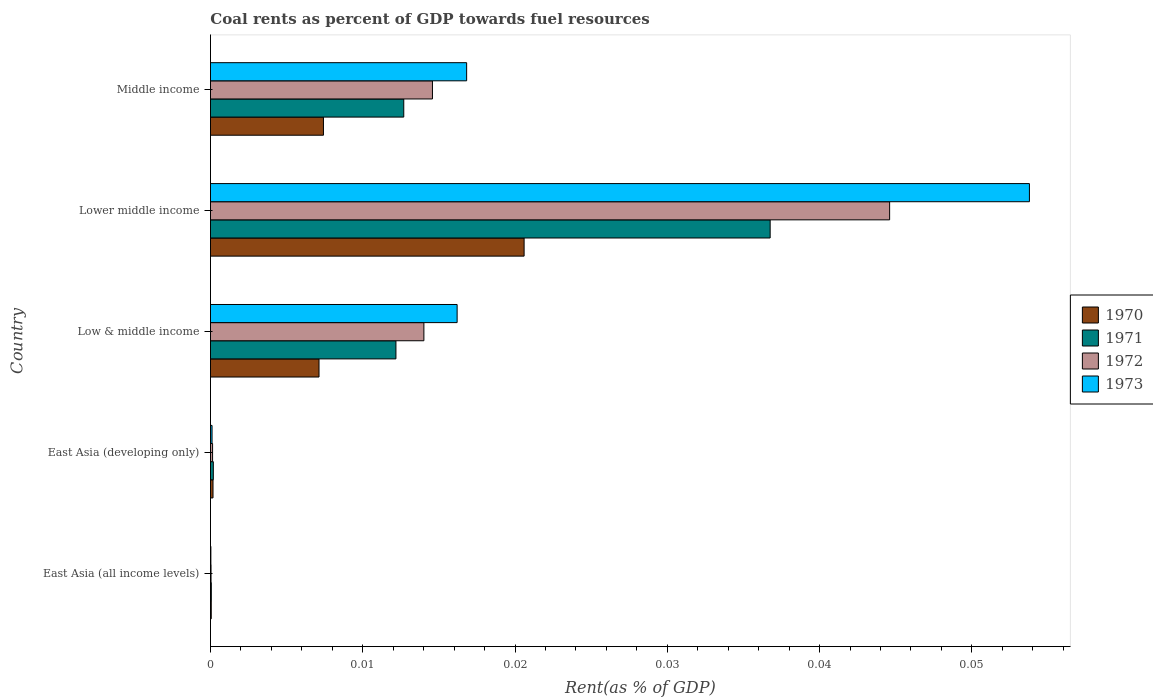How many groups of bars are there?
Provide a short and direct response. 5. Are the number of bars per tick equal to the number of legend labels?
Ensure brevity in your answer.  Yes. Are the number of bars on each tick of the Y-axis equal?
Your answer should be very brief. Yes. What is the label of the 2nd group of bars from the top?
Your response must be concise. Lower middle income. In how many cases, is the number of bars for a given country not equal to the number of legend labels?
Make the answer very short. 0. What is the coal rent in 1972 in Low & middle income?
Offer a very short reply. 0.01. Across all countries, what is the maximum coal rent in 1973?
Provide a succinct answer. 0.05. Across all countries, what is the minimum coal rent in 1973?
Your answer should be compact. 2.64171247686014e-5. In which country was the coal rent in 1971 maximum?
Your answer should be very brief. Lower middle income. In which country was the coal rent in 1972 minimum?
Your answer should be compact. East Asia (all income levels). What is the total coal rent in 1970 in the graph?
Your answer should be compact. 0.04. What is the difference between the coal rent in 1971 in Low & middle income and that in Middle income?
Your answer should be compact. -0. What is the difference between the coal rent in 1973 in Lower middle income and the coal rent in 1971 in East Asia (developing only)?
Give a very brief answer. 0.05. What is the average coal rent in 1970 per country?
Ensure brevity in your answer.  0.01. What is the difference between the coal rent in 1973 and coal rent in 1970 in Middle income?
Your answer should be very brief. 0.01. What is the ratio of the coal rent in 1971 in Low & middle income to that in Lower middle income?
Your answer should be compact. 0.33. Is the difference between the coal rent in 1973 in East Asia (all income levels) and Low & middle income greater than the difference between the coal rent in 1970 in East Asia (all income levels) and Low & middle income?
Make the answer very short. No. What is the difference between the highest and the second highest coal rent in 1970?
Offer a terse response. 0.01. What is the difference between the highest and the lowest coal rent in 1973?
Offer a very short reply. 0.05. Is the sum of the coal rent in 1971 in Lower middle income and Middle income greater than the maximum coal rent in 1973 across all countries?
Keep it short and to the point. No. What does the 1st bar from the top in Low & middle income represents?
Your response must be concise. 1973. How many bars are there?
Make the answer very short. 20. Does the graph contain any zero values?
Give a very brief answer. No. How many legend labels are there?
Give a very brief answer. 4. What is the title of the graph?
Ensure brevity in your answer.  Coal rents as percent of GDP towards fuel resources. What is the label or title of the X-axis?
Offer a terse response. Rent(as % of GDP). What is the label or title of the Y-axis?
Provide a succinct answer. Country. What is the Rent(as % of GDP) of 1970 in East Asia (all income levels)?
Offer a very short reply. 5.1314079013758e-5. What is the Rent(as % of GDP) in 1971 in East Asia (all income levels)?
Make the answer very short. 5.470114168356261e-5. What is the Rent(as % of GDP) in 1972 in East Asia (all income levels)?
Ensure brevity in your answer.  3.67730514806032e-5. What is the Rent(as % of GDP) of 1973 in East Asia (all income levels)?
Your answer should be compact. 2.64171247686014e-5. What is the Rent(as % of GDP) in 1970 in East Asia (developing only)?
Keep it short and to the point. 0. What is the Rent(as % of GDP) in 1971 in East Asia (developing only)?
Your response must be concise. 0. What is the Rent(as % of GDP) of 1972 in East Asia (developing only)?
Provide a succinct answer. 0. What is the Rent(as % of GDP) of 1973 in East Asia (developing only)?
Keep it short and to the point. 0. What is the Rent(as % of GDP) in 1970 in Low & middle income?
Your response must be concise. 0.01. What is the Rent(as % of GDP) in 1971 in Low & middle income?
Provide a succinct answer. 0.01. What is the Rent(as % of GDP) in 1972 in Low & middle income?
Your answer should be very brief. 0.01. What is the Rent(as % of GDP) in 1973 in Low & middle income?
Offer a terse response. 0.02. What is the Rent(as % of GDP) in 1970 in Lower middle income?
Your answer should be very brief. 0.02. What is the Rent(as % of GDP) of 1971 in Lower middle income?
Keep it short and to the point. 0.04. What is the Rent(as % of GDP) of 1972 in Lower middle income?
Your answer should be compact. 0.04. What is the Rent(as % of GDP) of 1973 in Lower middle income?
Make the answer very short. 0.05. What is the Rent(as % of GDP) of 1970 in Middle income?
Provide a short and direct response. 0.01. What is the Rent(as % of GDP) in 1971 in Middle income?
Give a very brief answer. 0.01. What is the Rent(as % of GDP) of 1972 in Middle income?
Provide a short and direct response. 0.01. What is the Rent(as % of GDP) of 1973 in Middle income?
Keep it short and to the point. 0.02. Across all countries, what is the maximum Rent(as % of GDP) of 1970?
Offer a terse response. 0.02. Across all countries, what is the maximum Rent(as % of GDP) in 1971?
Make the answer very short. 0.04. Across all countries, what is the maximum Rent(as % of GDP) in 1972?
Ensure brevity in your answer.  0.04. Across all countries, what is the maximum Rent(as % of GDP) of 1973?
Keep it short and to the point. 0.05. Across all countries, what is the minimum Rent(as % of GDP) in 1970?
Make the answer very short. 5.1314079013758e-5. Across all countries, what is the minimum Rent(as % of GDP) in 1971?
Ensure brevity in your answer.  5.470114168356261e-5. Across all countries, what is the minimum Rent(as % of GDP) in 1972?
Your answer should be very brief. 3.67730514806032e-5. Across all countries, what is the minimum Rent(as % of GDP) in 1973?
Your response must be concise. 2.64171247686014e-5. What is the total Rent(as % of GDP) in 1970 in the graph?
Give a very brief answer. 0.04. What is the total Rent(as % of GDP) in 1971 in the graph?
Offer a very short reply. 0.06. What is the total Rent(as % of GDP) in 1972 in the graph?
Offer a very short reply. 0.07. What is the total Rent(as % of GDP) in 1973 in the graph?
Your answer should be very brief. 0.09. What is the difference between the Rent(as % of GDP) of 1970 in East Asia (all income levels) and that in East Asia (developing only)?
Make the answer very short. -0. What is the difference between the Rent(as % of GDP) in 1971 in East Asia (all income levels) and that in East Asia (developing only)?
Make the answer very short. -0. What is the difference between the Rent(as % of GDP) in 1972 in East Asia (all income levels) and that in East Asia (developing only)?
Give a very brief answer. -0. What is the difference between the Rent(as % of GDP) in 1973 in East Asia (all income levels) and that in East Asia (developing only)?
Your response must be concise. -0. What is the difference between the Rent(as % of GDP) in 1970 in East Asia (all income levels) and that in Low & middle income?
Your answer should be compact. -0.01. What is the difference between the Rent(as % of GDP) in 1971 in East Asia (all income levels) and that in Low & middle income?
Your response must be concise. -0.01. What is the difference between the Rent(as % of GDP) of 1972 in East Asia (all income levels) and that in Low & middle income?
Keep it short and to the point. -0.01. What is the difference between the Rent(as % of GDP) in 1973 in East Asia (all income levels) and that in Low & middle income?
Provide a succinct answer. -0.02. What is the difference between the Rent(as % of GDP) of 1970 in East Asia (all income levels) and that in Lower middle income?
Offer a terse response. -0.02. What is the difference between the Rent(as % of GDP) of 1971 in East Asia (all income levels) and that in Lower middle income?
Keep it short and to the point. -0.04. What is the difference between the Rent(as % of GDP) in 1972 in East Asia (all income levels) and that in Lower middle income?
Your response must be concise. -0.04. What is the difference between the Rent(as % of GDP) of 1973 in East Asia (all income levels) and that in Lower middle income?
Your response must be concise. -0.05. What is the difference between the Rent(as % of GDP) of 1970 in East Asia (all income levels) and that in Middle income?
Offer a very short reply. -0.01. What is the difference between the Rent(as % of GDP) in 1971 in East Asia (all income levels) and that in Middle income?
Offer a terse response. -0.01. What is the difference between the Rent(as % of GDP) of 1972 in East Asia (all income levels) and that in Middle income?
Your response must be concise. -0.01. What is the difference between the Rent(as % of GDP) in 1973 in East Asia (all income levels) and that in Middle income?
Your response must be concise. -0.02. What is the difference between the Rent(as % of GDP) in 1970 in East Asia (developing only) and that in Low & middle income?
Make the answer very short. -0.01. What is the difference between the Rent(as % of GDP) of 1971 in East Asia (developing only) and that in Low & middle income?
Keep it short and to the point. -0.01. What is the difference between the Rent(as % of GDP) of 1972 in East Asia (developing only) and that in Low & middle income?
Your answer should be very brief. -0.01. What is the difference between the Rent(as % of GDP) in 1973 in East Asia (developing only) and that in Low & middle income?
Provide a short and direct response. -0.02. What is the difference between the Rent(as % of GDP) of 1970 in East Asia (developing only) and that in Lower middle income?
Provide a short and direct response. -0.02. What is the difference between the Rent(as % of GDP) of 1971 in East Asia (developing only) and that in Lower middle income?
Provide a short and direct response. -0.04. What is the difference between the Rent(as % of GDP) of 1972 in East Asia (developing only) and that in Lower middle income?
Offer a very short reply. -0.04. What is the difference between the Rent(as % of GDP) of 1973 in East Asia (developing only) and that in Lower middle income?
Offer a very short reply. -0.05. What is the difference between the Rent(as % of GDP) in 1970 in East Asia (developing only) and that in Middle income?
Ensure brevity in your answer.  -0.01. What is the difference between the Rent(as % of GDP) in 1971 in East Asia (developing only) and that in Middle income?
Give a very brief answer. -0.01. What is the difference between the Rent(as % of GDP) of 1972 in East Asia (developing only) and that in Middle income?
Provide a succinct answer. -0.01. What is the difference between the Rent(as % of GDP) in 1973 in East Asia (developing only) and that in Middle income?
Your response must be concise. -0.02. What is the difference between the Rent(as % of GDP) of 1970 in Low & middle income and that in Lower middle income?
Provide a succinct answer. -0.01. What is the difference between the Rent(as % of GDP) in 1971 in Low & middle income and that in Lower middle income?
Your answer should be very brief. -0.02. What is the difference between the Rent(as % of GDP) of 1972 in Low & middle income and that in Lower middle income?
Give a very brief answer. -0.03. What is the difference between the Rent(as % of GDP) of 1973 in Low & middle income and that in Lower middle income?
Offer a very short reply. -0.04. What is the difference between the Rent(as % of GDP) in 1970 in Low & middle income and that in Middle income?
Offer a very short reply. -0. What is the difference between the Rent(as % of GDP) in 1971 in Low & middle income and that in Middle income?
Offer a terse response. -0. What is the difference between the Rent(as % of GDP) in 1972 in Low & middle income and that in Middle income?
Provide a succinct answer. -0. What is the difference between the Rent(as % of GDP) of 1973 in Low & middle income and that in Middle income?
Provide a short and direct response. -0. What is the difference between the Rent(as % of GDP) in 1970 in Lower middle income and that in Middle income?
Your response must be concise. 0.01. What is the difference between the Rent(as % of GDP) in 1971 in Lower middle income and that in Middle income?
Provide a short and direct response. 0.02. What is the difference between the Rent(as % of GDP) in 1973 in Lower middle income and that in Middle income?
Your answer should be compact. 0.04. What is the difference between the Rent(as % of GDP) in 1970 in East Asia (all income levels) and the Rent(as % of GDP) in 1971 in East Asia (developing only)?
Your response must be concise. -0. What is the difference between the Rent(as % of GDP) in 1970 in East Asia (all income levels) and the Rent(as % of GDP) in 1972 in East Asia (developing only)?
Keep it short and to the point. -0. What is the difference between the Rent(as % of GDP) in 1970 in East Asia (all income levels) and the Rent(as % of GDP) in 1973 in East Asia (developing only)?
Your answer should be compact. -0. What is the difference between the Rent(as % of GDP) of 1971 in East Asia (all income levels) and the Rent(as % of GDP) of 1972 in East Asia (developing only)?
Ensure brevity in your answer.  -0. What is the difference between the Rent(as % of GDP) of 1972 in East Asia (all income levels) and the Rent(as % of GDP) of 1973 in East Asia (developing only)?
Ensure brevity in your answer.  -0. What is the difference between the Rent(as % of GDP) in 1970 in East Asia (all income levels) and the Rent(as % of GDP) in 1971 in Low & middle income?
Your response must be concise. -0.01. What is the difference between the Rent(as % of GDP) of 1970 in East Asia (all income levels) and the Rent(as % of GDP) of 1972 in Low & middle income?
Provide a short and direct response. -0.01. What is the difference between the Rent(as % of GDP) in 1970 in East Asia (all income levels) and the Rent(as % of GDP) in 1973 in Low & middle income?
Your answer should be compact. -0.02. What is the difference between the Rent(as % of GDP) of 1971 in East Asia (all income levels) and the Rent(as % of GDP) of 1972 in Low & middle income?
Provide a succinct answer. -0.01. What is the difference between the Rent(as % of GDP) in 1971 in East Asia (all income levels) and the Rent(as % of GDP) in 1973 in Low & middle income?
Give a very brief answer. -0.02. What is the difference between the Rent(as % of GDP) of 1972 in East Asia (all income levels) and the Rent(as % of GDP) of 1973 in Low & middle income?
Keep it short and to the point. -0.02. What is the difference between the Rent(as % of GDP) of 1970 in East Asia (all income levels) and the Rent(as % of GDP) of 1971 in Lower middle income?
Make the answer very short. -0.04. What is the difference between the Rent(as % of GDP) of 1970 in East Asia (all income levels) and the Rent(as % of GDP) of 1972 in Lower middle income?
Provide a succinct answer. -0.04. What is the difference between the Rent(as % of GDP) in 1970 in East Asia (all income levels) and the Rent(as % of GDP) in 1973 in Lower middle income?
Offer a terse response. -0.05. What is the difference between the Rent(as % of GDP) in 1971 in East Asia (all income levels) and the Rent(as % of GDP) in 1972 in Lower middle income?
Provide a succinct answer. -0.04. What is the difference between the Rent(as % of GDP) of 1971 in East Asia (all income levels) and the Rent(as % of GDP) of 1973 in Lower middle income?
Your answer should be compact. -0.05. What is the difference between the Rent(as % of GDP) in 1972 in East Asia (all income levels) and the Rent(as % of GDP) in 1973 in Lower middle income?
Offer a very short reply. -0.05. What is the difference between the Rent(as % of GDP) of 1970 in East Asia (all income levels) and the Rent(as % of GDP) of 1971 in Middle income?
Offer a very short reply. -0.01. What is the difference between the Rent(as % of GDP) of 1970 in East Asia (all income levels) and the Rent(as % of GDP) of 1972 in Middle income?
Keep it short and to the point. -0.01. What is the difference between the Rent(as % of GDP) in 1970 in East Asia (all income levels) and the Rent(as % of GDP) in 1973 in Middle income?
Your response must be concise. -0.02. What is the difference between the Rent(as % of GDP) of 1971 in East Asia (all income levels) and the Rent(as % of GDP) of 1972 in Middle income?
Your answer should be very brief. -0.01. What is the difference between the Rent(as % of GDP) in 1971 in East Asia (all income levels) and the Rent(as % of GDP) in 1973 in Middle income?
Provide a short and direct response. -0.02. What is the difference between the Rent(as % of GDP) in 1972 in East Asia (all income levels) and the Rent(as % of GDP) in 1973 in Middle income?
Ensure brevity in your answer.  -0.02. What is the difference between the Rent(as % of GDP) of 1970 in East Asia (developing only) and the Rent(as % of GDP) of 1971 in Low & middle income?
Give a very brief answer. -0.01. What is the difference between the Rent(as % of GDP) in 1970 in East Asia (developing only) and the Rent(as % of GDP) in 1972 in Low & middle income?
Your answer should be very brief. -0.01. What is the difference between the Rent(as % of GDP) of 1970 in East Asia (developing only) and the Rent(as % of GDP) of 1973 in Low & middle income?
Give a very brief answer. -0.02. What is the difference between the Rent(as % of GDP) of 1971 in East Asia (developing only) and the Rent(as % of GDP) of 1972 in Low & middle income?
Offer a terse response. -0.01. What is the difference between the Rent(as % of GDP) in 1971 in East Asia (developing only) and the Rent(as % of GDP) in 1973 in Low & middle income?
Make the answer very short. -0.02. What is the difference between the Rent(as % of GDP) of 1972 in East Asia (developing only) and the Rent(as % of GDP) of 1973 in Low & middle income?
Give a very brief answer. -0.02. What is the difference between the Rent(as % of GDP) of 1970 in East Asia (developing only) and the Rent(as % of GDP) of 1971 in Lower middle income?
Provide a short and direct response. -0.04. What is the difference between the Rent(as % of GDP) in 1970 in East Asia (developing only) and the Rent(as % of GDP) in 1972 in Lower middle income?
Your answer should be compact. -0.04. What is the difference between the Rent(as % of GDP) of 1970 in East Asia (developing only) and the Rent(as % of GDP) of 1973 in Lower middle income?
Give a very brief answer. -0.05. What is the difference between the Rent(as % of GDP) of 1971 in East Asia (developing only) and the Rent(as % of GDP) of 1972 in Lower middle income?
Your response must be concise. -0.04. What is the difference between the Rent(as % of GDP) in 1971 in East Asia (developing only) and the Rent(as % of GDP) in 1973 in Lower middle income?
Provide a short and direct response. -0.05. What is the difference between the Rent(as % of GDP) in 1972 in East Asia (developing only) and the Rent(as % of GDP) in 1973 in Lower middle income?
Make the answer very short. -0.05. What is the difference between the Rent(as % of GDP) in 1970 in East Asia (developing only) and the Rent(as % of GDP) in 1971 in Middle income?
Provide a succinct answer. -0.01. What is the difference between the Rent(as % of GDP) in 1970 in East Asia (developing only) and the Rent(as % of GDP) in 1972 in Middle income?
Your answer should be very brief. -0.01. What is the difference between the Rent(as % of GDP) of 1970 in East Asia (developing only) and the Rent(as % of GDP) of 1973 in Middle income?
Your answer should be compact. -0.02. What is the difference between the Rent(as % of GDP) of 1971 in East Asia (developing only) and the Rent(as % of GDP) of 1972 in Middle income?
Your answer should be compact. -0.01. What is the difference between the Rent(as % of GDP) in 1971 in East Asia (developing only) and the Rent(as % of GDP) in 1973 in Middle income?
Ensure brevity in your answer.  -0.02. What is the difference between the Rent(as % of GDP) in 1972 in East Asia (developing only) and the Rent(as % of GDP) in 1973 in Middle income?
Give a very brief answer. -0.02. What is the difference between the Rent(as % of GDP) in 1970 in Low & middle income and the Rent(as % of GDP) in 1971 in Lower middle income?
Offer a terse response. -0.03. What is the difference between the Rent(as % of GDP) in 1970 in Low & middle income and the Rent(as % of GDP) in 1972 in Lower middle income?
Make the answer very short. -0.04. What is the difference between the Rent(as % of GDP) of 1970 in Low & middle income and the Rent(as % of GDP) of 1973 in Lower middle income?
Offer a terse response. -0.05. What is the difference between the Rent(as % of GDP) of 1971 in Low & middle income and the Rent(as % of GDP) of 1972 in Lower middle income?
Offer a very short reply. -0.03. What is the difference between the Rent(as % of GDP) in 1971 in Low & middle income and the Rent(as % of GDP) in 1973 in Lower middle income?
Provide a short and direct response. -0.04. What is the difference between the Rent(as % of GDP) in 1972 in Low & middle income and the Rent(as % of GDP) in 1973 in Lower middle income?
Offer a very short reply. -0.04. What is the difference between the Rent(as % of GDP) in 1970 in Low & middle income and the Rent(as % of GDP) in 1971 in Middle income?
Ensure brevity in your answer.  -0.01. What is the difference between the Rent(as % of GDP) of 1970 in Low & middle income and the Rent(as % of GDP) of 1972 in Middle income?
Provide a succinct answer. -0.01. What is the difference between the Rent(as % of GDP) of 1970 in Low & middle income and the Rent(as % of GDP) of 1973 in Middle income?
Give a very brief answer. -0.01. What is the difference between the Rent(as % of GDP) of 1971 in Low & middle income and the Rent(as % of GDP) of 1972 in Middle income?
Ensure brevity in your answer.  -0. What is the difference between the Rent(as % of GDP) of 1971 in Low & middle income and the Rent(as % of GDP) of 1973 in Middle income?
Your answer should be compact. -0. What is the difference between the Rent(as % of GDP) of 1972 in Low & middle income and the Rent(as % of GDP) of 1973 in Middle income?
Give a very brief answer. -0. What is the difference between the Rent(as % of GDP) of 1970 in Lower middle income and the Rent(as % of GDP) of 1971 in Middle income?
Offer a terse response. 0.01. What is the difference between the Rent(as % of GDP) of 1970 in Lower middle income and the Rent(as % of GDP) of 1972 in Middle income?
Offer a terse response. 0.01. What is the difference between the Rent(as % of GDP) in 1970 in Lower middle income and the Rent(as % of GDP) in 1973 in Middle income?
Make the answer very short. 0. What is the difference between the Rent(as % of GDP) of 1971 in Lower middle income and the Rent(as % of GDP) of 1972 in Middle income?
Give a very brief answer. 0.02. What is the difference between the Rent(as % of GDP) of 1971 in Lower middle income and the Rent(as % of GDP) of 1973 in Middle income?
Make the answer very short. 0.02. What is the difference between the Rent(as % of GDP) in 1972 in Lower middle income and the Rent(as % of GDP) in 1973 in Middle income?
Offer a very short reply. 0.03. What is the average Rent(as % of GDP) in 1970 per country?
Give a very brief answer. 0.01. What is the average Rent(as % of GDP) of 1971 per country?
Give a very brief answer. 0.01. What is the average Rent(as % of GDP) in 1972 per country?
Make the answer very short. 0.01. What is the average Rent(as % of GDP) in 1973 per country?
Give a very brief answer. 0.02. What is the difference between the Rent(as % of GDP) in 1970 and Rent(as % of GDP) in 1971 in East Asia (all income levels)?
Provide a succinct answer. -0. What is the difference between the Rent(as % of GDP) in 1970 and Rent(as % of GDP) in 1972 in East Asia (all income levels)?
Give a very brief answer. 0. What is the difference between the Rent(as % of GDP) in 1971 and Rent(as % of GDP) in 1972 in East Asia (all income levels)?
Offer a terse response. 0. What is the difference between the Rent(as % of GDP) in 1970 and Rent(as % of GDP) in 1971 in East Asia (developing only)?
Offer a very short reply. -0. What is the difference between the Rent(as % of GDP) of 1970 and Rent(as % of GDP) of 1972 in East Asia (developing only)?
Make the answer very short. 0. What is the difference between the Rent(as % of GDP) in 1970 and Rent(as % of GDP) in 1971 in Low & middle income?
Keep it short and to the point. -0.01. What is the difference between the Rent(as % of GDP) of 1970 and Rent(as % of GDP) of 1972 in Low & middle income?
Provide a short and direct response. -0.01. What is the difference between the Rent(as % of GDP) of 1970 and Rent(as % of GDP) of 1973 in Low & middle income?
Give a very brief answer. -0.01. What is the difference between the Rent(as % of GDP) in 1971 and Rent(as % of GDP) in 1972 in Low & middle income?
Provide a succinct answer. -0. What is the difference between the Rent(as % of GDP) in 1971 and Rent(as % of GDP) in 1973 in Low & middle income?
Your answer should be compact. -0. What is the difference between the Rent(as % of GDP) in 1972 and Rent(as % of GDP) in 1973 in Low & middle income?
Keep it short and to the point. -0. What is the difference between the Rent(as % of GDP) of 1970 and Rent(as % of GDP) of 1971 in Lower middle income?
Make the answer very short. -0.02. What is the difference between the Rent(as % of GDP) of 1970 and Rent(as % of GDP) of 1972 in Lower middle income?
Keep it short and to the point. -0.02. What is the difference between the Rent(as % of GDP) in 1970 and Rent(as % of GDP) in 1973 in Lower middle income?
Offer a very short reply. -0.03. What is the difference between the Rent(as % of GDP) of 1971 and Rent(as % of GDP) of 1972 in Lower middle income?
Give a very brief answer. -0.01. What is the difference between the Rent(as % of GDP) in 1971 and Rent(as % of GDP) in 1973 in Lower middle income?
Provide a short and direct response. -0.02. What is the difference between the Rent(as % of GDP) in 1972 and Rent(as % of GDP) in 1973 in Lower middle income?
Ensure brevity in your answer.  -0.01. What is the difference between the Rent(as % of GDP) of 1970 and Rent(as % of GDP) of 1971 in Middle income?
Your response must be concise. -0.01. What is the difference between the Rent(as % of GDP) of 1970 and Rent(as % of GDP) of 1972 in Middle income?
Provide a short and direct response. -0.01. What is the difference between the Rent(as % of GDP) in 1970 and Rent(as % of GDP) in 1973 in Middle income?
Offer a terse response. -0.01. What is the difference between the Rent(as % of GDP) of 1971 and Rent(as % of GDP) of 1972 in Middle income?
Provide a short and direct response. -0. What is the difference between the Rent(as % of GDP) of 1971 and Rent(as % of GDP) of 1973 in Middle income?
Make the answer very short. -0. What is the difference between the Rent(as % of GDP) in 1972 and Rent(as % of GDP) in 1973 in Middle income?
Provide a short and direct response. -0. What is the ratio of the Rent(as % of GDP) of 1970 in East Asia (all income levels) to that in East Asia (developing only)?
Offer a very short reply. 0.31. What is the ratio of the Rent(as % of GDP) of 1971 in East Asia (all income levels) to that in East Asia (developing only)?
Provide a succinct answer. 0.29. What is the ratio of the Rent(as % of GDP) of 1972 in East Asia (all income levels) to that in East Asia (developing only)?
Provide a short and direct response. 0.27. What is the ratio of the Rent(as % of GDP) in 1973 in East Asia (all income levels) to that in East Asia (developing only)?
Ensure brevity in your answer.  0.26. What is the ratio of the Rent(as % of GDP) of 1970 in East Asia (all income levels) to that in Low & middle income?
Provide a succinct answer. 0.01. What is the ratio of the Rent(as % of GDP) of 1971 in East Asia (all income levels) to that in Low & middle income?
Make the answer very short. 0. What is the ratio of the Rent(as % of GDP) in 1972 in East Asia (all income levels) to that in Low & middle income?
Your response must be concise. 0. What is the ratio of the Rent(as % of GDP) of 1973 in East Asia (all income levels) to that in Low & middle income?
Provide a short and direct response. 0. What is the ratio of the Rent(as % of GDP) of 1970 in East Asia (all income levels) to that in Lower middle income?
Your response must be concise. 0. What is the ratio of the Rent(as % of GDP) in 1971 in East Asia (all income levels) to that in Lower middle income?
Provide a succinct answer. 0. What is the ratio of the Rent(as % of GDP) in 1972 in East Asia (all income levels) to that in Lower middle income?
Ensure brevity in your answer.  0. What is the ratio of the Rent(as % of GDP) of 1970 in East Asia (all income levels) to that in Middle income?
Offer a terse response. 0.01. What is the ratio of the Rent(as % of GDP) in 1971 in East Asia (all income levels) to that in Middle income?
Your response must be concise. 0. What is the ratio of the Rent(as % of GDP) of 1972 in East Asia (all income levels) to that in Middle income?
Keep it short and to the point. 0. What is the ratio of the Rent(as % of GDP) of 1973 in East Asia (all income levels) to that in Middle income?
Provide a succinct answer. 0. What is the ratio of the Rent(as % of GDP) of 1970 in East Asia (developing only) to that in Low & middle income?
Provide a succinct answer. 0.02. What is the ratio of the Rent(as % of GDP) in 1971 in East Asia (developing only) to that in Low & middle income?
Your answer should be compact. 0.02. What is the ratio of the Rent(as % of GDP) of 1972 in East Asia (developing only) to that in Low & middle income?
Make the answer very short. 0.01. What is the ratio of the Rent(as % of GDP) in 1973 in East Asia (developing only) to that in Low & middle income?
Keep it short and to the point. 0.01. What is the ratio of the Rent(as % of GDP) of 1970 in East Asia (developing only) to that in Lower middle income?
Your answer should be very brief. 0.01. What is the ratio of the Rent(as % of GDP) in 1971 in East Asia (developing only) to that in Lower middle income?
Your response must be concise. 0.01. What is the ratio of the Rent(as % of GDP) in 1972 in East Asia (developing only) to that in Lower middle income?
Your response must be concise. 0. What is the ratio of the Rent(as % of GDP) in 1973 in East Asia (developing only) to that in Lower middle income?
Your response must be concise. 0. What is the ratio of the Rent(as % of GDP) in 1970 in East Asia (developing only) to that in Middle income?
Offer a very short reply. 0.02. What is the ratio of the Rent(as % of GDP) in 1971 in East Asia (developing only) to that in Middle income?
Your answer should be very brief. 0.01. What is the ratio of the Rent(as % of GDP) in 1972 in East Asia (developing only) to that in Middle income?
Make the answer very short. 0.01. What is the ratio of the Rent(as % of GDP) of 1973 in East Asia (developing only) to that in Middle income?
Provide a succinct answer. 0.01. What is the ratio of the Rent(as % of GDP) of 1970 in Low & middle income to that in Lower middle income?
Make the answer very short. 0.35. What is the ratio of the Rent(as % of GDP) of 1971 in Low & middle income to that in Lower middle income?
Your response must be concise. 0.33. What is the ratio of the Rent(as % of GDP) of 1972 in Low & middle income to that in Lower middle income?
Offer a very short reply. 0.31. What is the ratio of the Rent(as % of GDP) in 1973 in Low & middle income to that in Lower middle income?
Keep it short and to the point. 0.3. What is the ratio of the Rent(as % of GDP) in 1970 in Low & middle income to that in Middle income?
Provide a succinct answer. 0.96. What is the ratio of the Rent(as % of GDP) of 1971 in Low & middle income to that in Middle income?
Give a very brief answer. 0.96. What is the ratio of the Rent(as % of GDP) of 1972 in Low & middle income to that in Middle income?
Ensure brevity in your answer.  0.96. What is the ratio of the Rent(as % of GDP) of 1973 in Low & middle income to that in Middle income?
Ensure brevity in your answer.  0.96. What is the ratio of the Rent(as % of GDP) of 1970 in Lower middle income to that in Middle income?
Make the answer very short. 2.78. What is the ratio of the Rent(as % of GDP) of 1971 in Lower middle income to that in Middle income?
Provide a short and direct response. 2.9. What is the ratio of the Rent(as % of GDP) in 1972 in Lower middle income to that in Middle income?
Your answer should be very brief. 3.06. What is the ratio of the Rent(as % of GDP) of 1973 in Lower middle income to that in Middle income?
Your answer should be very brief. 3.2. What is the difference between the highest and the second highest Rent(as % of GDP) of 1970?
Your answer should be compact. 0.01. What is the difference between the highest and the second highest Rent(as % of GDP) of 1971?
Make the answer very short. 0.02. What is the difference between the highest and the second highest Rent(as % of GDP) in 1972?
Your answer should be very brief. 0.03. What is the difference between the highest and the second highest Rent(as % of GDP) of 1973?
Provide a succinct answer. 0.04. What is the difference between the highest and the lowest Rent(as % of GDP) of 1970?
Your response must be concise. 0.02. What is the difference between the highest and the lowest Rent(as % of GDP) of 1971?
Provide a succinct answer. 0.04. What is the difference between the highest and the lowest Rent(as % of GDP) in 1972?
Keep it short and to the point. 0.04. What is the difference between the highest and the lowest Rent(as % of GDP) of 1973?
Offer a very short reply. 0.05. 